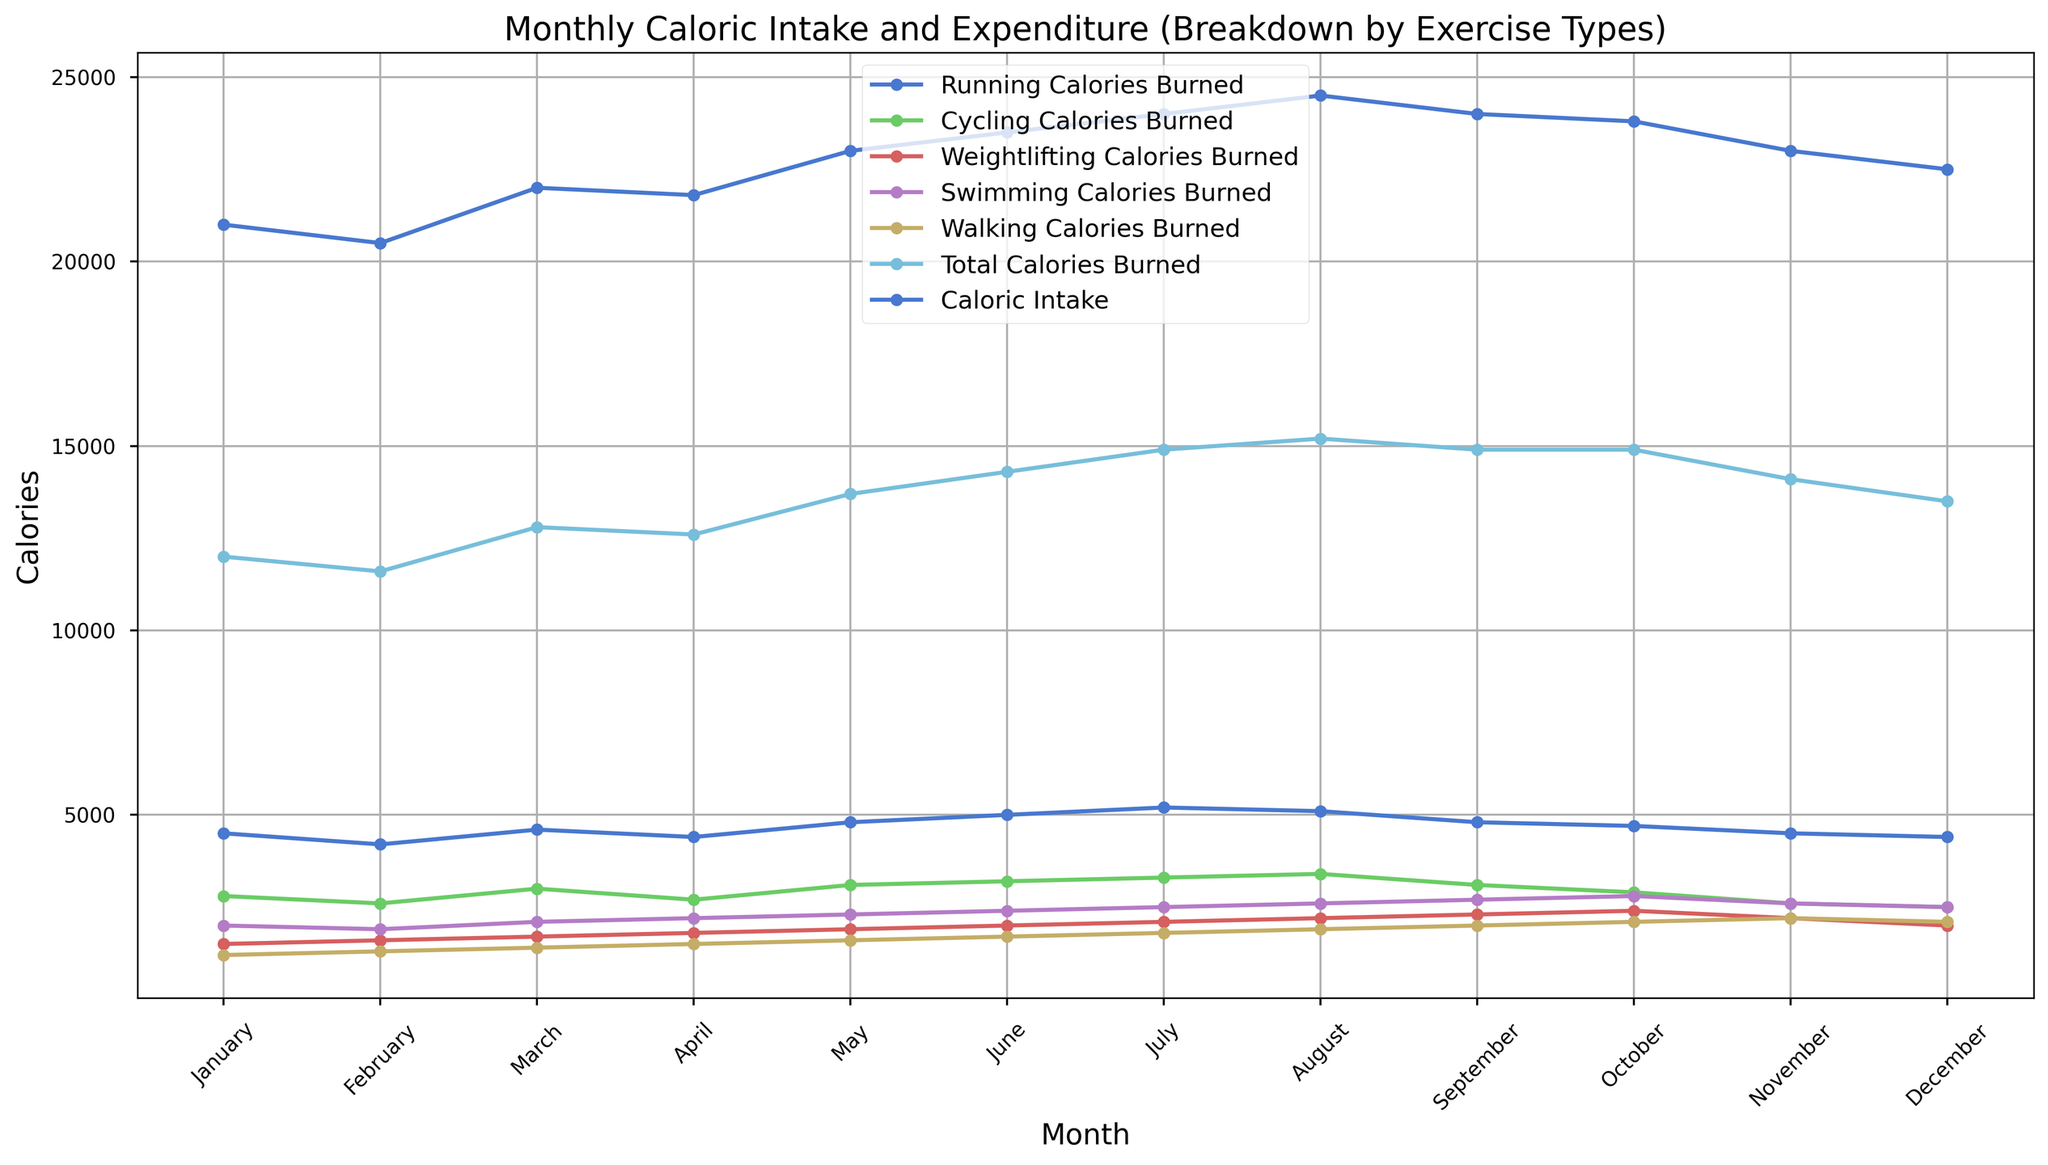What is the overall trend observed in the Total Calories Burned throughout the year? By observing the line representing Total Calories Burned, we can see that it generally increases from January to August, peaks around mid-year, and then gradually decreases towards December.
Answer: The trend is a gradual increase until August, then a decrease towards December Which month has the highest Total Calories Burned? By noting the highest point on the Total Calories Burned line, August shows the peak value indicating the highest total calories burned in that month.
Answer: August In which month is the gap between Caloric Intake and Total Calories Burned the largest? The gap is calculated as the difference between Caloric Intake and Total Calories Burned for each month. Observing visually where the vertical distance between these two lines is greatest, May has the largest gap.
Answer: May How does the caloric expenditure from Running compare to Swimming in July? By comparing the points for Running and Swimming in July, we see that the calories burned running are higher than those burned swimming.
Answer: Running > Swimming Which exercise activity shows a steady increase in calories burned from January to December? Looking at each exercise line individually, Walking shows a steady gradual increase over the months without significant drops.
Answer: Walking Is there any month where the Total Calories Burned exceeds Caloric Intake? Observing the lines for Caloric Intake and Total Calories Burned, there are no months where the Total Calories Burned line goes above the Caloric Intake line.
Answer: No How much was the average difference between Caloric Intake and Total Calories Burned for the year? First, calculate the difference for each month and then find the average of these values: (21000-12000 + 20500-11600 + 22000-12800 + 21800-12600 + 23000-13700 + 23500-14300 + 24000-14900 + 24500-15200 + 24000-14900 + 23800-14900 + 23000-14100 + 22500-13500) / 12 = 9100 / 12 = 758.33
Answer: 758.33 Which exercise type contributed the most to caloric expenditure in June? By observing the points for each exercise type in June, Running has the highest caloric expenditure compared to other exercises.
Answer: Running What are the total calories burned through Walking in the whole year? Sum the calories burned walking for each month: 1200 + 1300 + 1400 + 1500 + 1600 + 1700 + 1800 + 1900 + 2000 + 2100 + 2200 + 2100 = 21800
Answer: 21800 